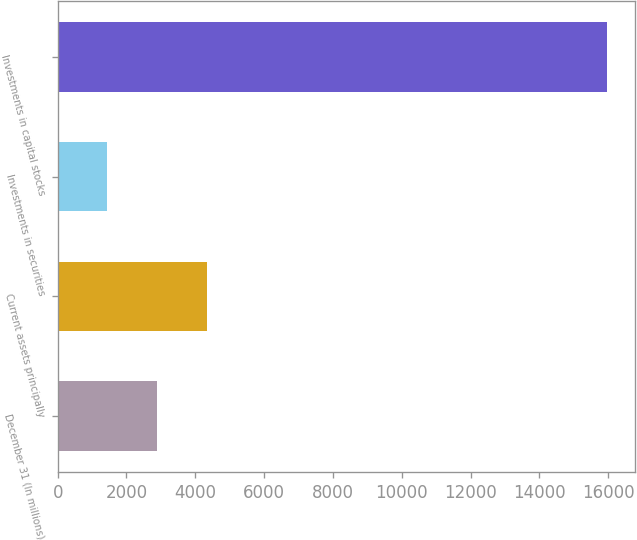Convert chart to OTSL. <chart><loc_0><loc_0><loc_500><loc_500><bar_chart><fcel>December 31 (In millions)<fcel>Current assets principally<fcel>Investments in securities<fcel>Investments in capital stocks<nl><fcel>2892.5<fcel>4346<fcel>1439<fcel>15974<nl></chart> 